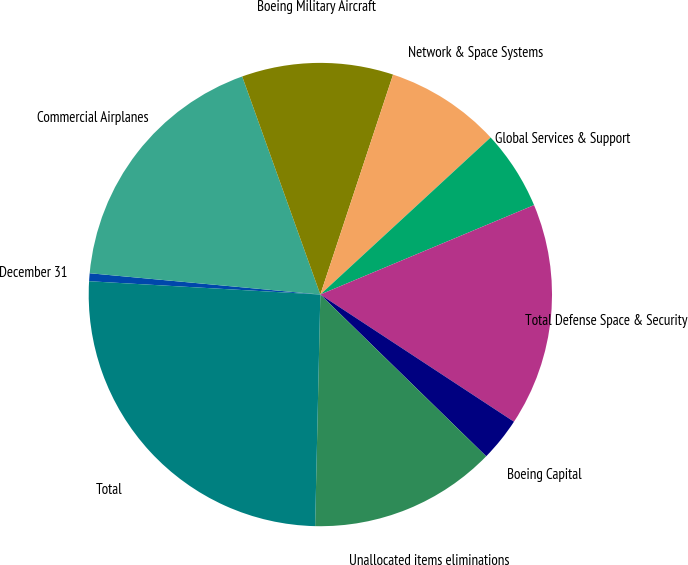Convert chart to OTSL. <chart><loc_0><loc_0><loc_500><loc_500><pie_chart><fcel>December 31<fcel>Commercial Airplanes<fcel>Boeing Military Aircraft<fcel>Network & Space Systems<fcel>Global Services & Support<fcel>Total Defense Space & Security<fcel>Boeing Capital<fcel>Unallocated items eliminations<fcel>Total<nl><fcel>0.55%<fcel>18.06%<fcel>10.56%<fcel>8.06%<fcel>5.55%<fcel>15.56%<fcel>3.05%<fcel>13.06%<fcel>25.56%<nl></chart> 